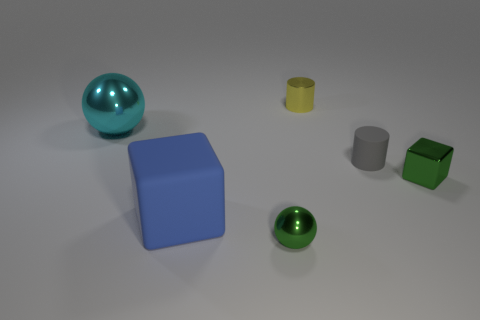Add 4 small green shiny things. How many objects exist? 10 Subtract all cubes. How many objects are left? 4 Add 1 shiny blocks. How many shiny blocks are left? 2 Add 5 large cyan shiny balls. How many large cyan shiny balls exist? 6 Subtract 0 brown cylinders. How many objects are left? 6 Subtract all large cyan metallic blocks. Subtract all small metallic cubes. How many objects are left? 5 